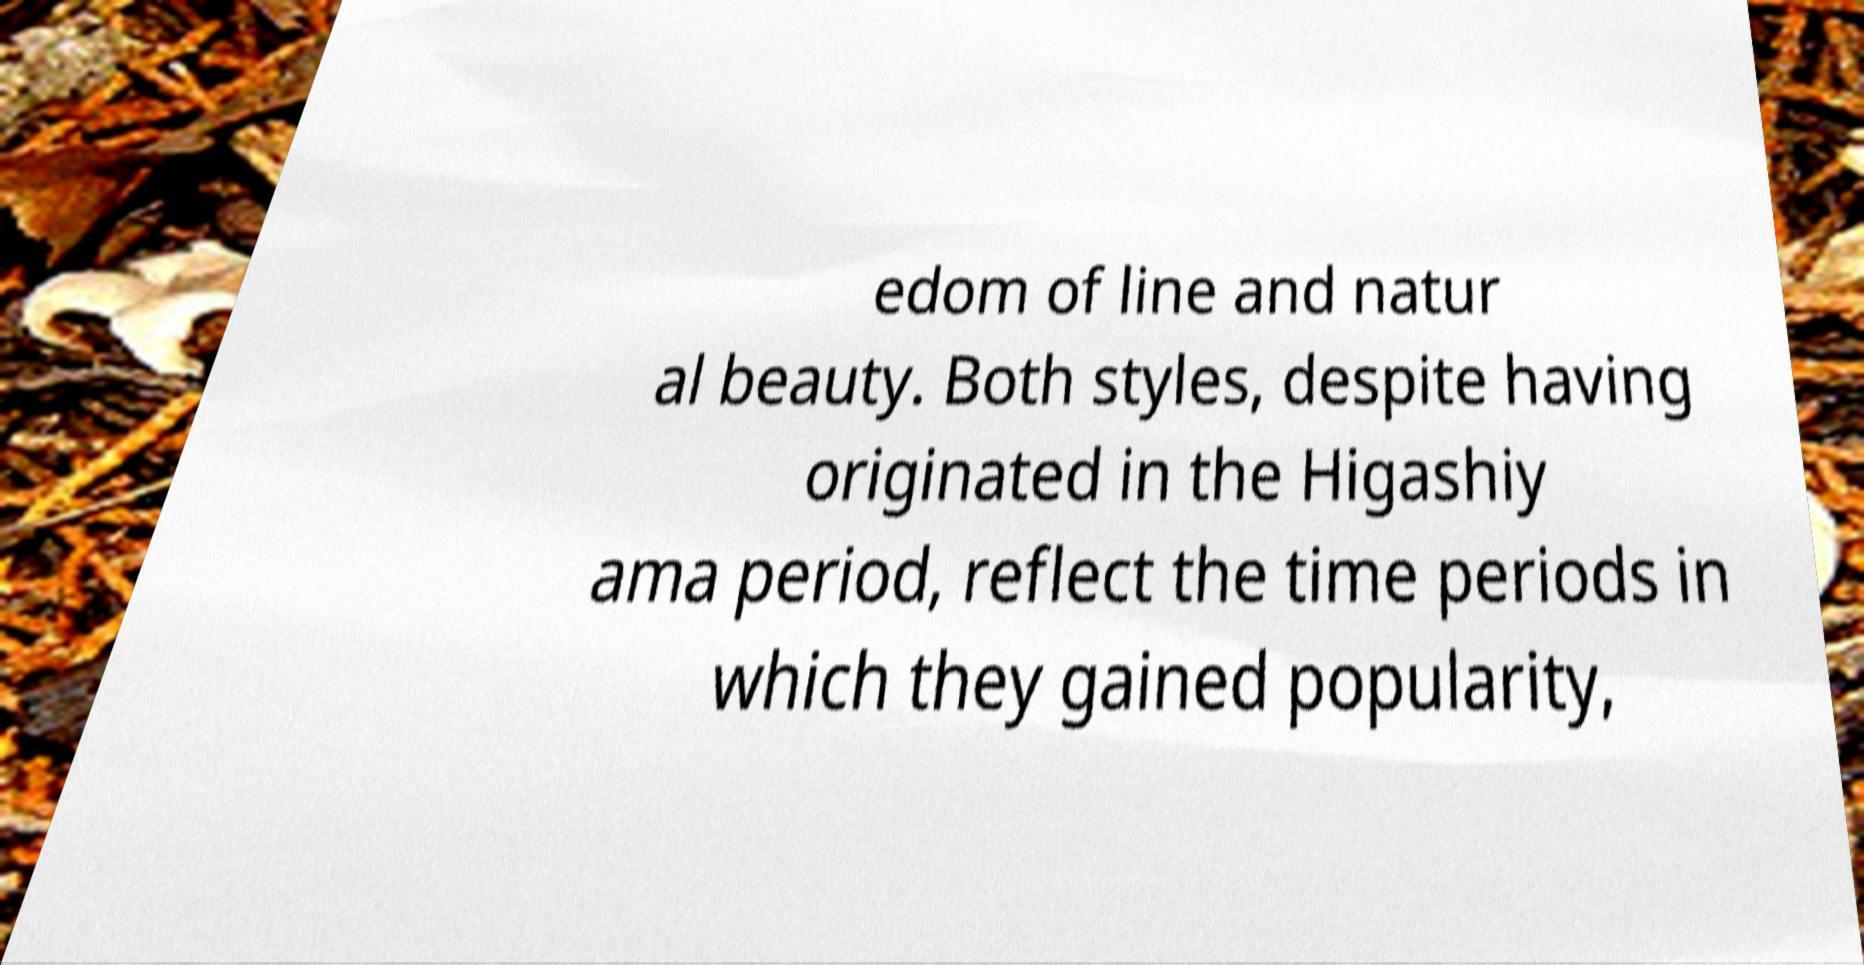Can you read and provide the text displayed in the image?This photo seems to have some interesting text. Can you extract and type it out for me? edom of line and natur al beauty. Both styles, despite having originated in the Higashiy ama period, reflect the time periods in which they gained popularity, 